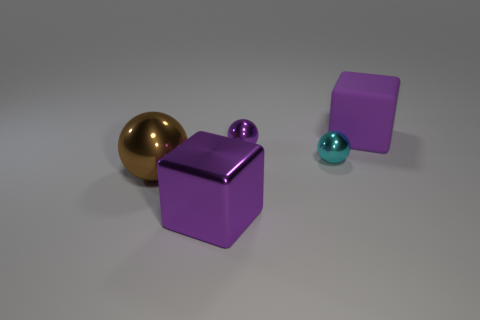What number of shiny spheres are right of the shiny cube and left of the metal cube?
Ensure brevity in your answer.  0. The big metallic thing right of the sphere that is on the left side of the large cube that is in front of the matte object is what shape?
Offer a very short reply. Cube. Is there anything else that is the same shape as the large matte object?
Offer a terse response. Yes. How many cylinders are small things or small cyan objects?
Your answer should be compact. 0. Does the big block that is to the left of the rubber thing have the same color as the big rubber cube?
Offer a terse response. Yes. What is the purple object that is in front of the metallic thing that is left of the big purple thing that is to the left of the matte block made of?
Ensure brevity in your answer.  Metal. Do the purple metal sphere and the cyan ball have the same size?
Give a very brief answer. Yes. Does the big rubber cube have the same color as the large metallic object in front of the big shiny sphere?
Provide a short and direct response. Yes. There is a big purple thing that is made of the same material as the brown sphere; what is its shape?
Offer a very short reply. Cube. Does the thing left of the big metallic block have the same shape as the tiny purple thing?
Provide a succinct answer. Yes. 